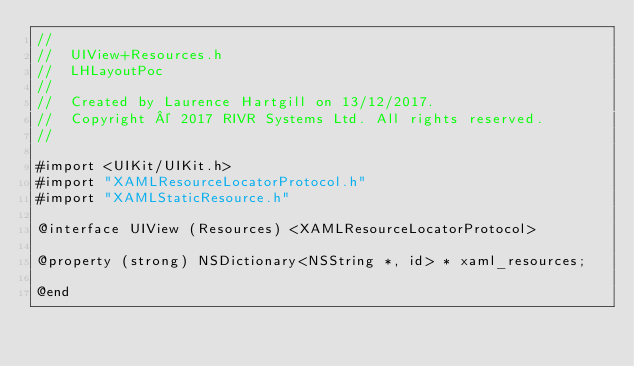<code> <loc_0><loc_0><loc_500><loc_500><_C_>//
//  UIView+Resources.h
//  LHLayoutPoc
//
//  Created by Laurence Hartgill on 13/12/2017.
//  Copyright © 2017 RIVR Systems Ltd. All rights reserved.
//

#import <UIKit/UIKit.h>
#import "XAMLResourceLocatorProtocol.h"
#import "XAMLStaticResource.h"

@interface UIView (Resources) <XAMLResourceLocatorProtocol>

@property (strong) NSDictionary<NSString *, id> * xaml_resources;

@end
</code> 